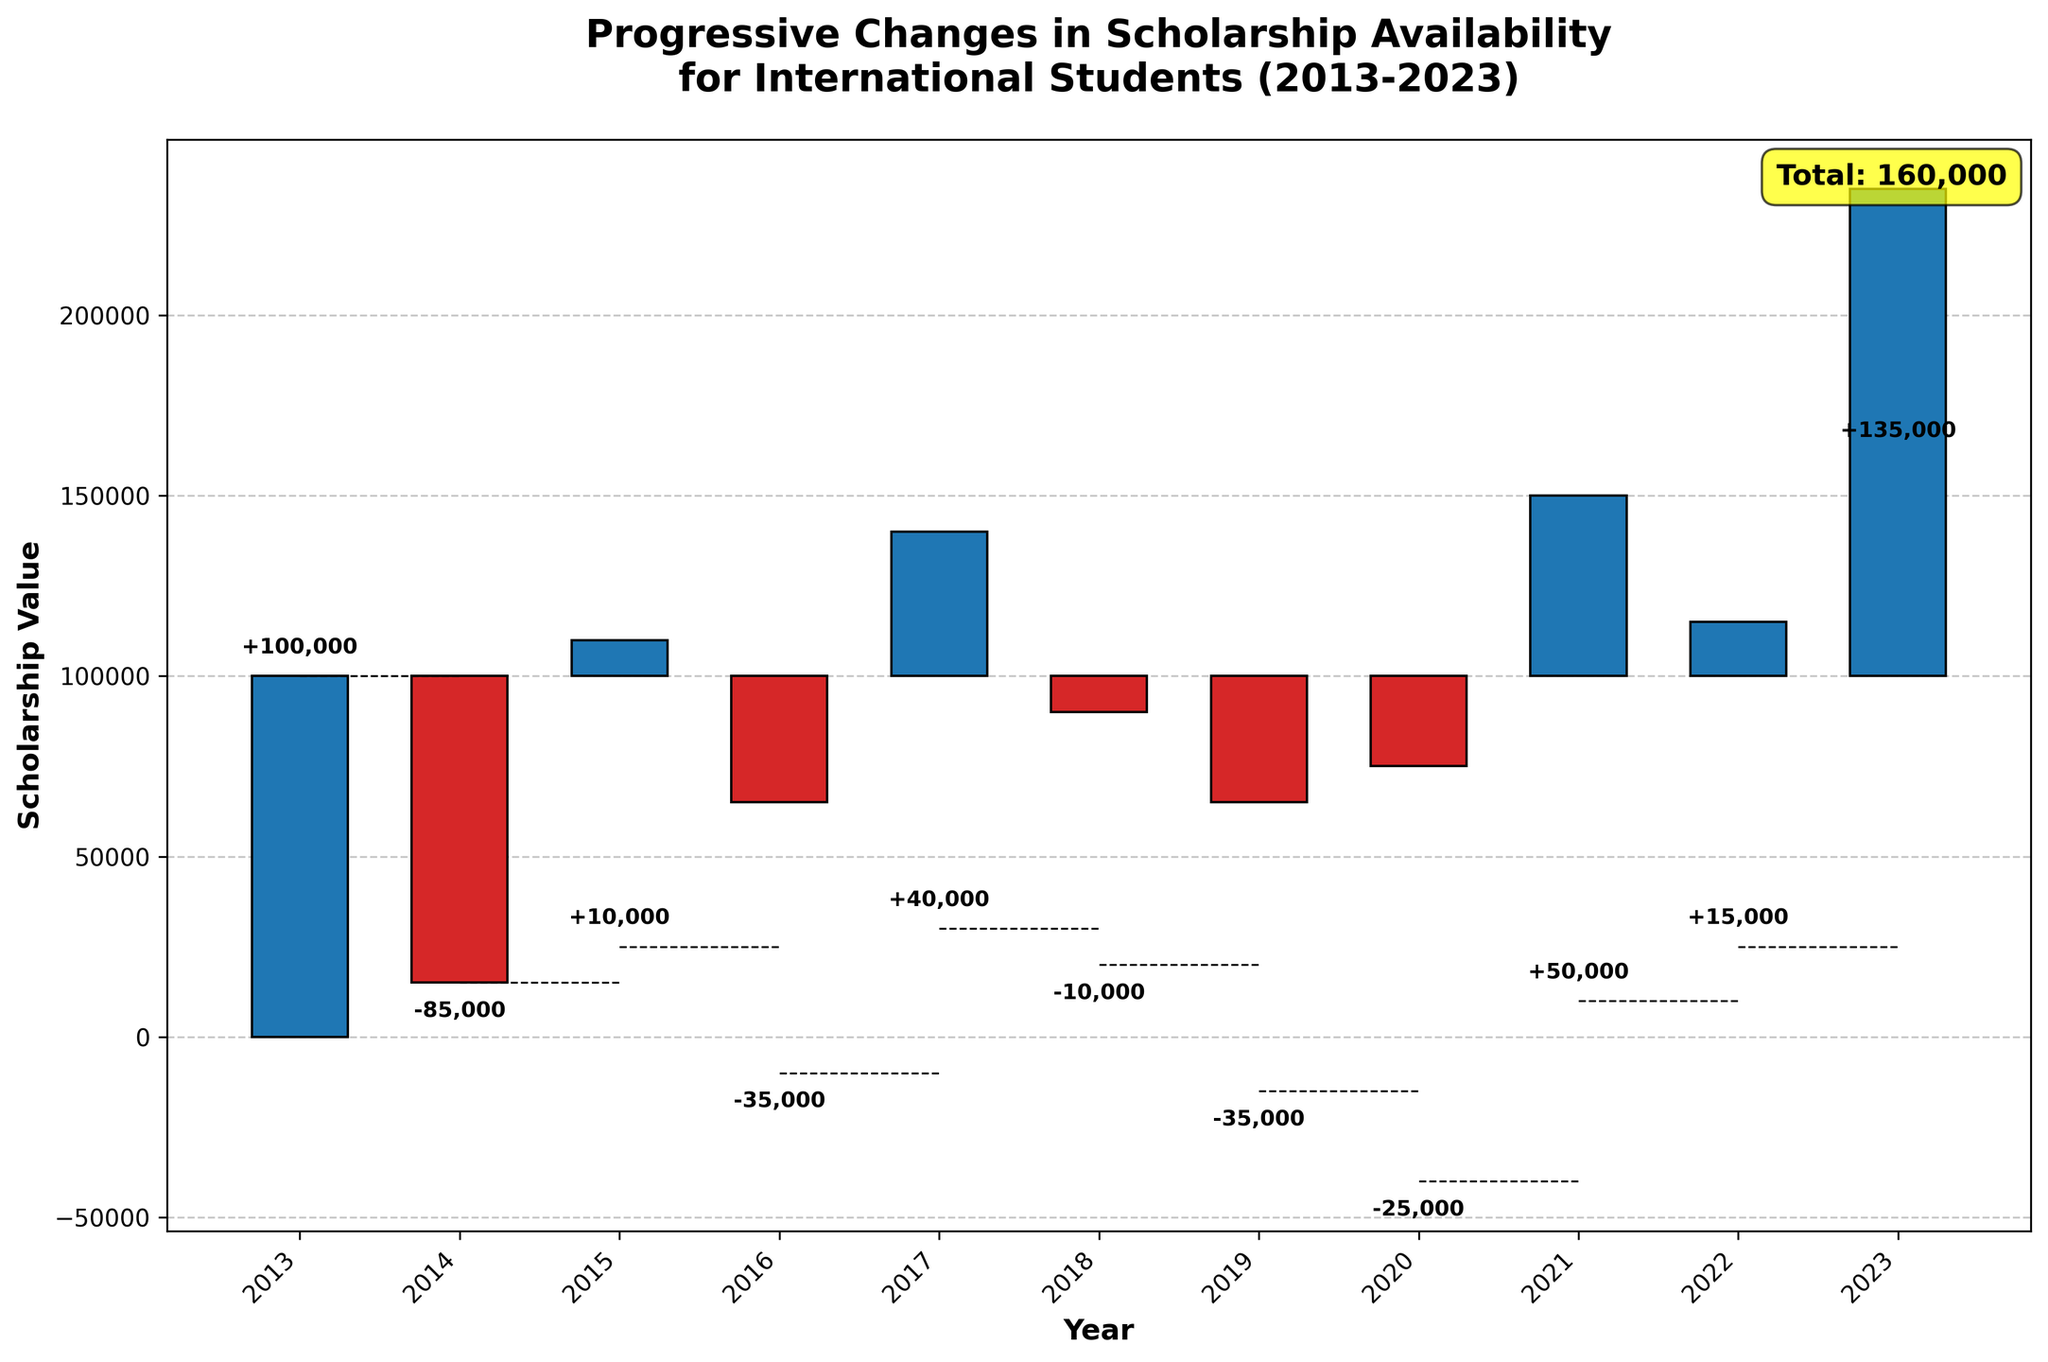What is the title of the chart? The title is located at the top of the figure and describes what the chart represents: "Progressive Changes in Scholarship Availability for International Students (2013-2023)."
Answer: Progressive Changes in Scholarship Availability for International Students (2013-2023) In which year was there the highest positive change in scholarship availability? By comparing the height of the positive bars, the year with the highest positive change is 2017, due to the "Launch of China Scholarship Council programs" with a change of 30,000.
Answer: 2017 What is the total scholarship value by the end of 2023? The total value is usually displayed at the end of the chart and often highlighted; in this chart, the annotation "Total: 160,000" at the top-right corner indicates the total value.
Answer: 160,000 Which years had negative changes in scholarship availability? Negative changes are represented by red bars in the chart. The red bars appear in 2016 (Decrease in Commonwealth Scholarships), 2019 (Reduction in US institution-specific scholarships), and 2020 (COVID-19 impact on scholarship funding).
Answer: 2016, 2019, 2020 How much did scholarship availability decrease in 2020 due to COVID-19? The value for the year 2020 can be found by looking at the label on the respective bar, which shows a decrease of 40,000.
Answer: 40,000 What was the net change in scholarship availability from 2013 to 2014? From the figure, in 2014, the change is "Increase in Fulbright Scholarships" with a value of 15,000. This can be interpreted directly from the height of the bar corresponding to this change.
Answer: 15,000 From 2013 to 2014, and 2015 to 2016, which period experienced a larger change in scholarship availability? The first period (2013 to 2014) saw an increase of 15,000, while the second period (2015 to 2016) involves two changes: an introduction of Erasmus Mundus Scholarships (+25,000) and a decrease in Commonwealth Scholarships (-10,000). The net change in the second period is +15,000, the same as the first period.
Answer: The same What was the cumulative impact on scholarship availability over the 2019 and 2020 periods? Adding the changes from 2019 and 2020, there is a reduction of 15,000 and 40,000 respectively, resulting in a total reduction of 55,000.
Answer: -55,000 Which year started with a scholarship value and ended with the largest increase in scholarship value? In 2017, there was a large positive change due to the "Launch of China Scholarship Council programs" which added 30,000, the highest change in a single year.
Answer: 2017 